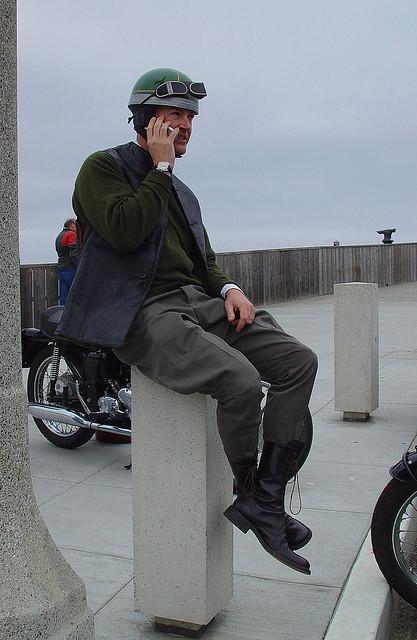The man sitting on the post with the phone to his ear is wearing what color of dome on his hat?
Choose the correct response, then elucidate: 'Answer: answer
Rationale: rationale.'
Options: Red, blue, yellow, green. Answer: green.
Rationale: Unless you are colorblind you can easily tell what color the helmet is. 